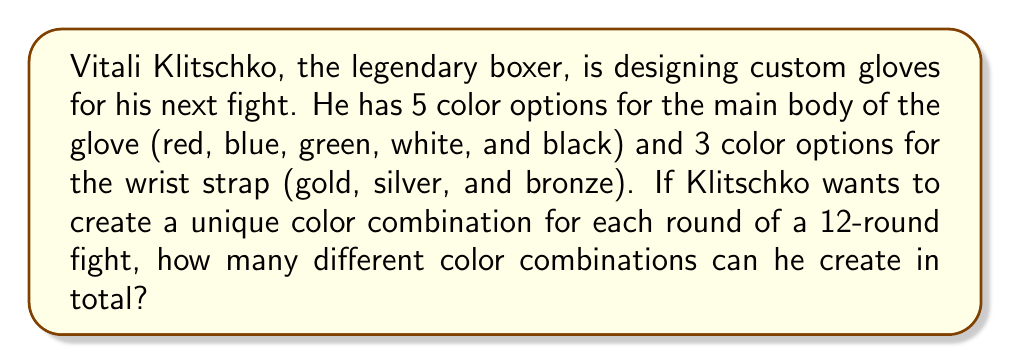Can you answer this question? Let's approach this step-by-step:

1) We need to use the multiplication principle of counting here. This principle states that if we have $m$ ways of doing something and $n$ ways of doing another thing, then there are $m \times n$ ways of doing both things.

2) For the main body of the glove:
   - There are 5 color options
   
3) For the wrist strap:
   - There are 3 color options

4) For each main body color, Klitschko can choose any of the 3 wrist strap colors. Therefore, the total number of combinations is:

   $$ \text{Total combinations} = \text{Body color options} \times \text{Wrist strap color options} $$
   $$ \text{Total combinations} = 5 \times 3 = 15 $$

5) We can verify that this is enough for a 12-round fight:
   $15 > 12$, so Klitschko has more than enough combinations for each round to be unique.
Answer: 15 combinations 